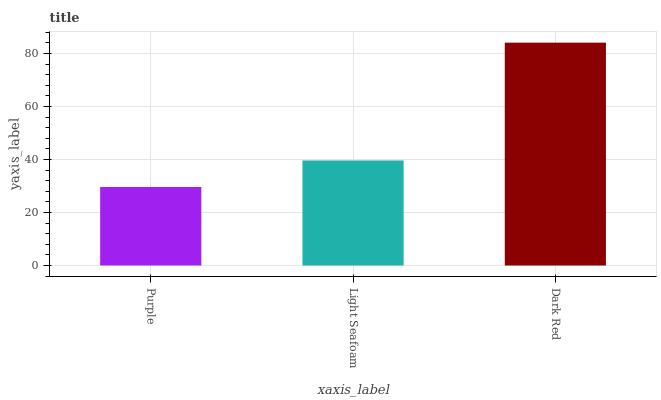Is Purple the minimum?
Answer yes or no. Yes. Is Dark Red the maximum?
Answer yes or no. Yes. Is Light Seafoam the minimum?
Answer yes or no. No. Is Light Seafoam the maximum?
Answer yes or no. No. Is Light Seafoam greater than Purple?
Answer yes or no. Yes. Is Purple less than Light Seafoam?
Answer yes or no. Yes. Is Purple greater than Light Seafoam?
Answer yes or no. No. Is Light Seafoam less than Purple?
Answer yes or no. No. Is Light Seafoam the high median?
Answer yes or no. Yes. Is Light Seafoam the low median?
Answer yes or no. Yes. Is Purple the high median?
Answer yes or no. No. Is Purple the low median?
Answer yes or no. No. 